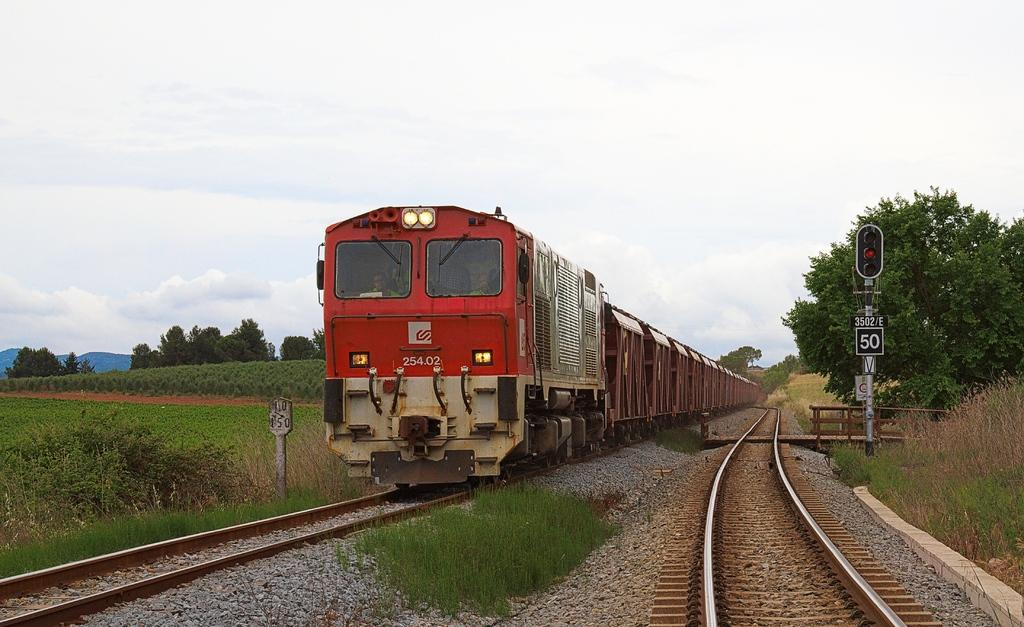<image>
Provide a brief description of the given image. A red train has the code 254.02 on the front of it. 